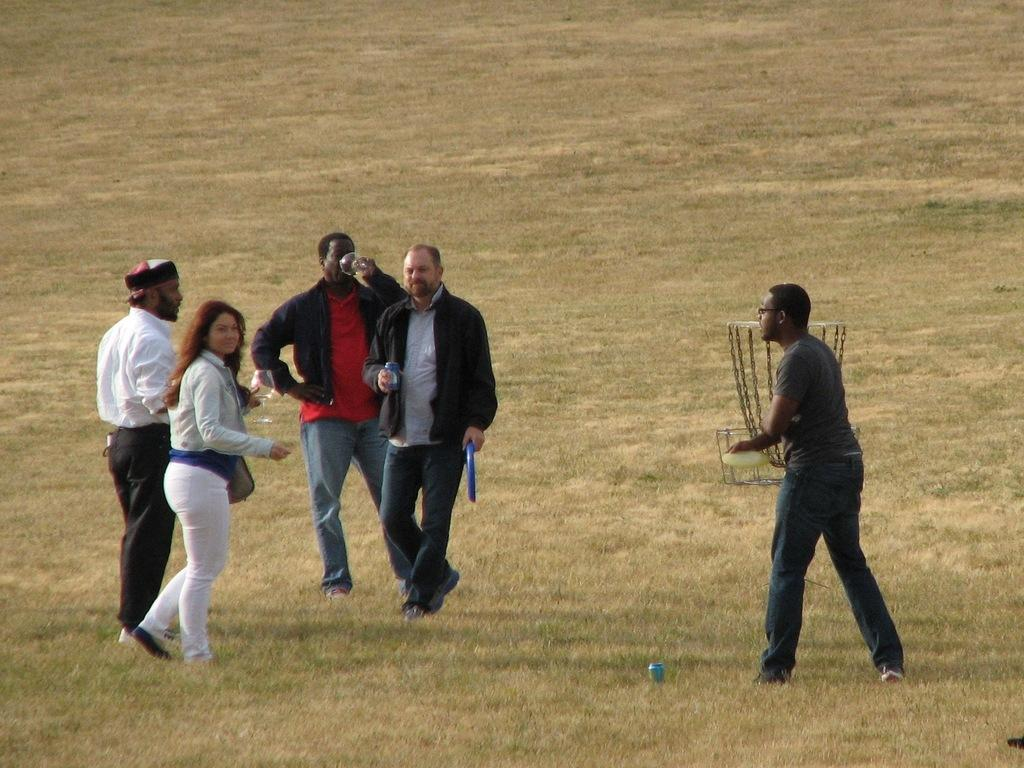What is happening in the center of the image? There are people standing in the center of the image. What are the people holding in their hands? The people are holding objects. What type of natural environment can be seen in the background of the image? There is grass visible in the background of the image. What type of ice can be seen melting on the ground in the image? There is no ice present in the image; it features people standing and holding objects. Can you tell me where the badge is located in the image? There is no badge mentioned or visible in the image. 